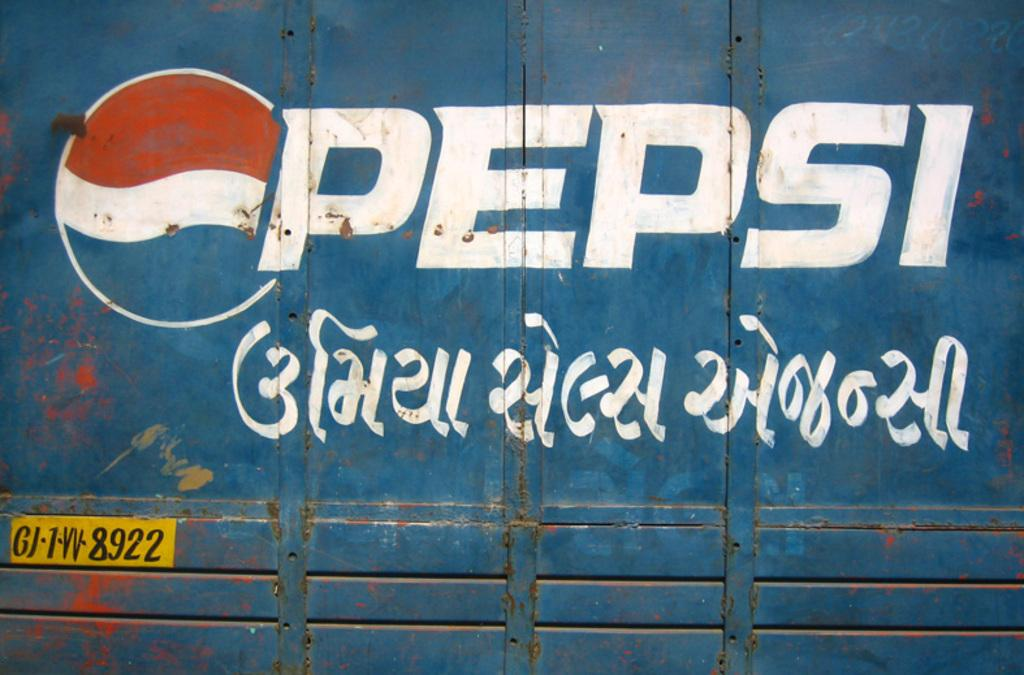<image>
Describe the image concisely. A shipping container with the Pepsi logo on it with some foreign writing under it. 